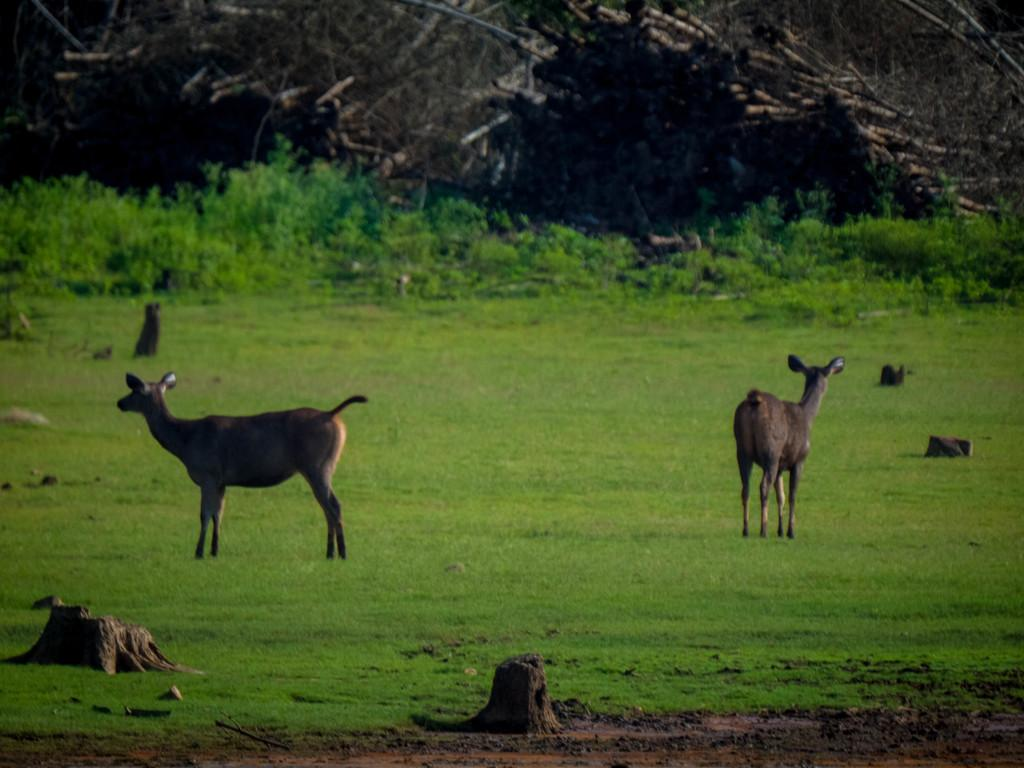What is located in the middle of the image? There are animals in the middle of the image. What type of vegetation can be seen in the image? There is grass in the image. What can be seen in the background of the image? There are trees visible at the top of the image. What type of locket can be seen hanging from the tree in the image? There is no locket present in the image; it only features animals, grass, and trees. 